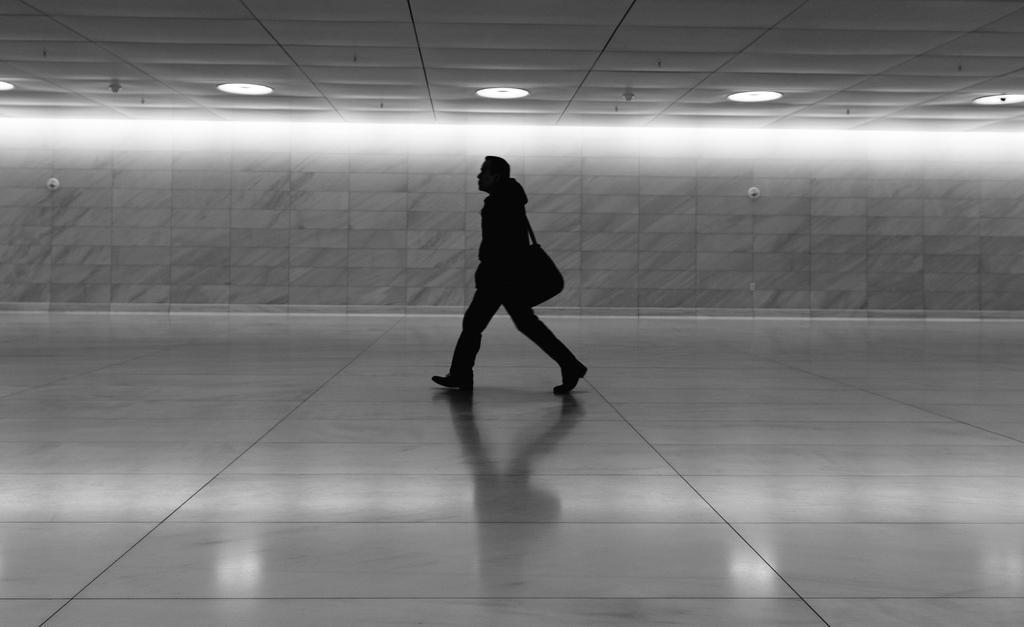Could you give a brief overview of what you see in this image? In the center of the image we can see a man walking. He is wearing a bag. In the background there is a wall. At the top there are lights. 